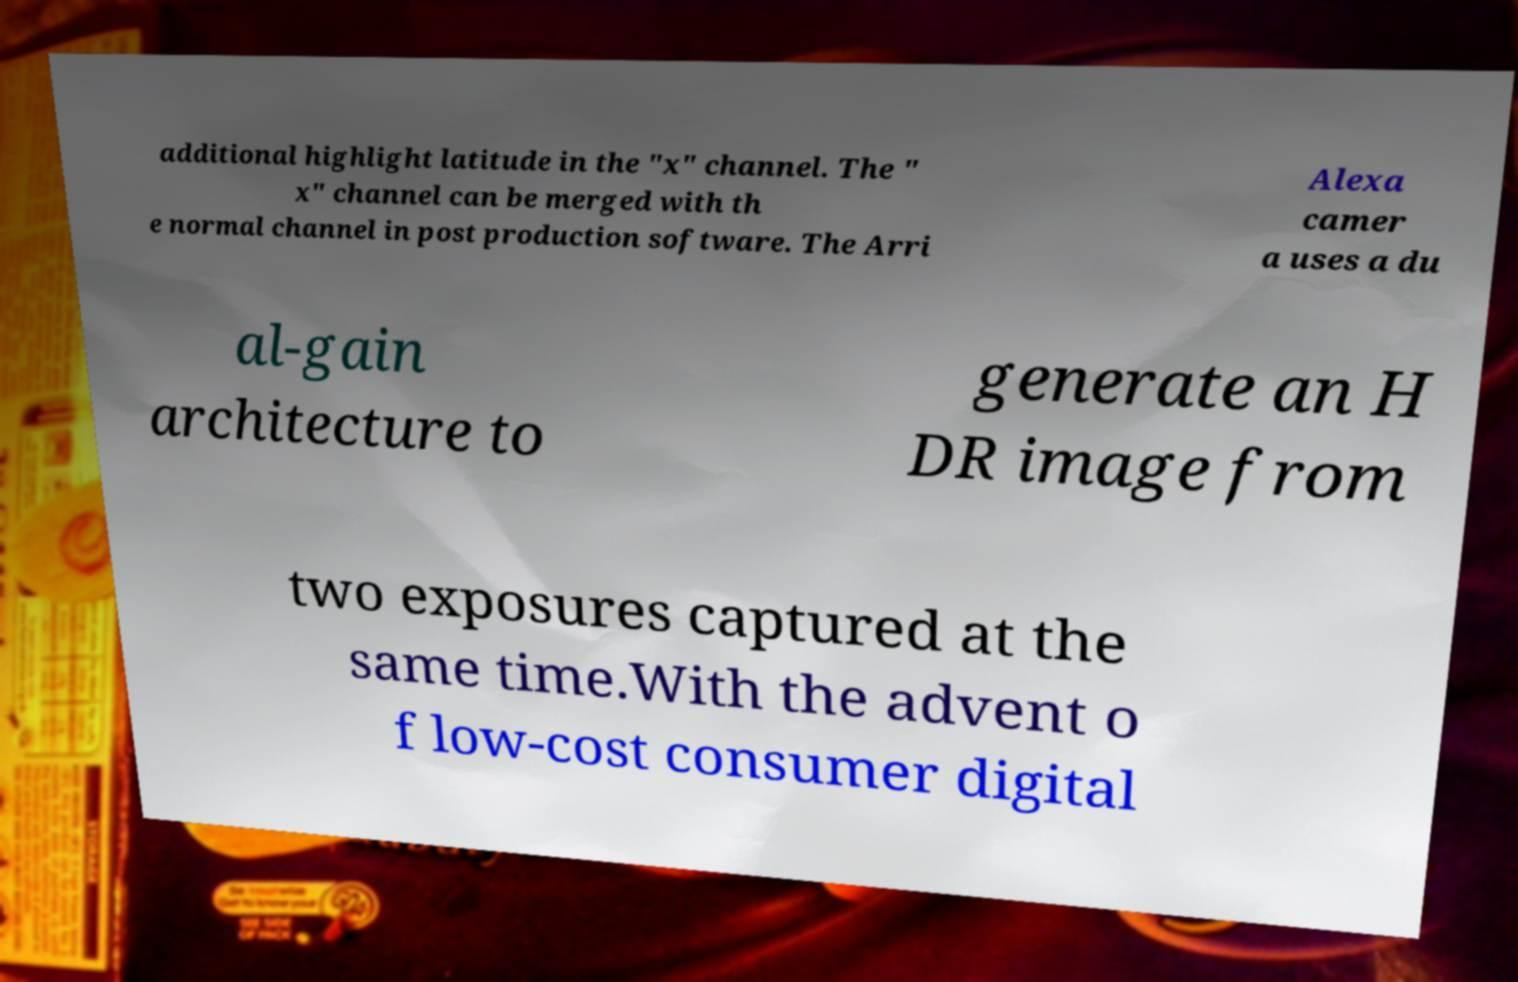Can you read and provide the text displayed in the image?This photo seems to have some interesting text. Can you extract and type it out for me? additional highlight latitude in the "x" channel. The " x" channel can be merged with th e normal channel in post production software. The Arri Alexa camer a uses a du al-gain architecture to generate an H DR image from two exposures captured at the same time.With the advent o f low-cost consumer digital 